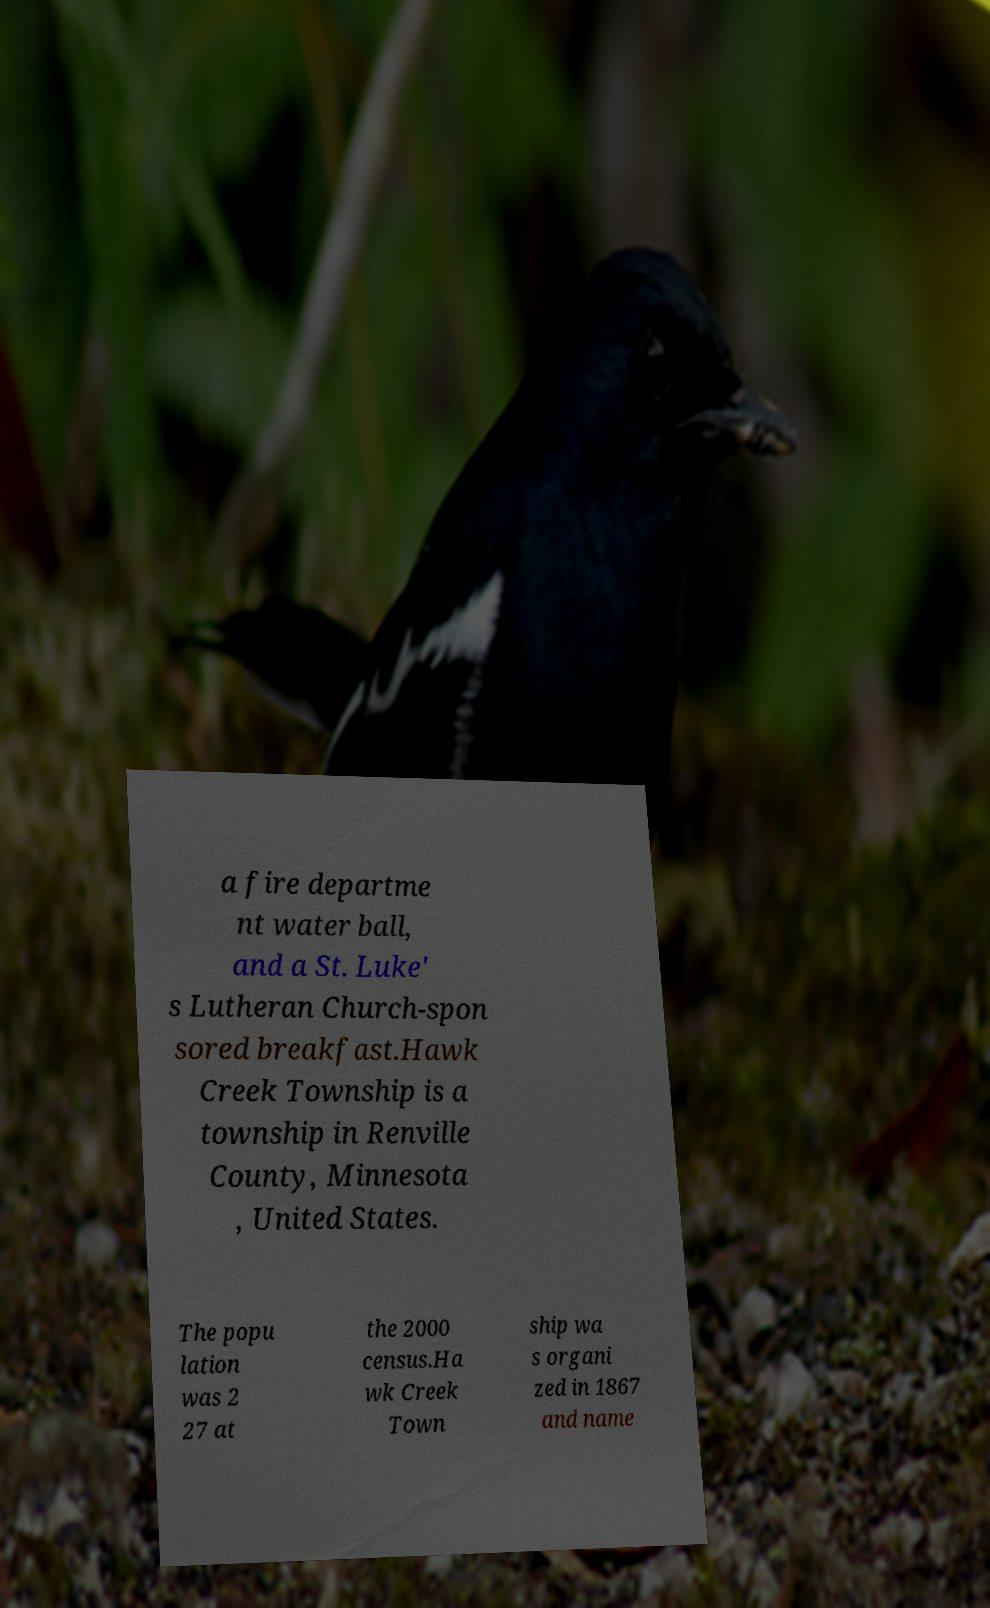There's text embedded in this image that I need extracted. Can you transcribe it verbatim? a fire departme nt water ball, and a St. Luke' s Lutheran Church-spon sored breakfast.Hawk Creek Township is a township in Renville County, Minnesota , United States. The popu lation was 2 27 at the 2000 census.Ha wk Creek Town ship wa s organi zed in 1867 and name 